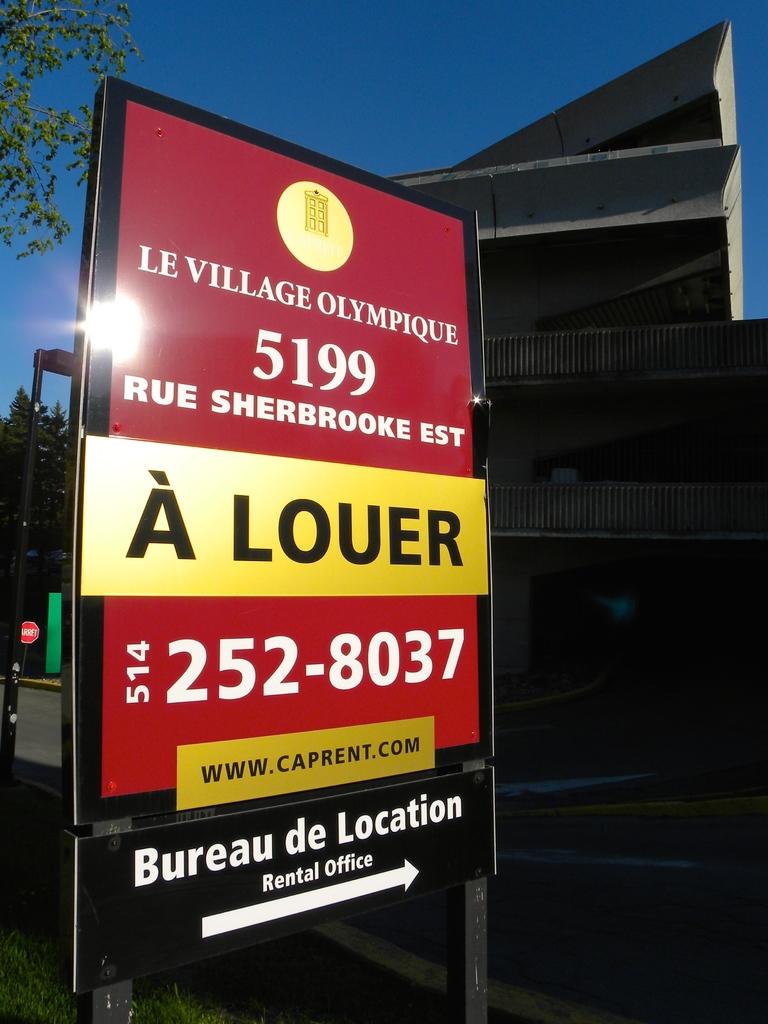What is the phone number?
Provide a short and direct response. 5142528037. What is the building number?
Your answer should be compact. 5199. 